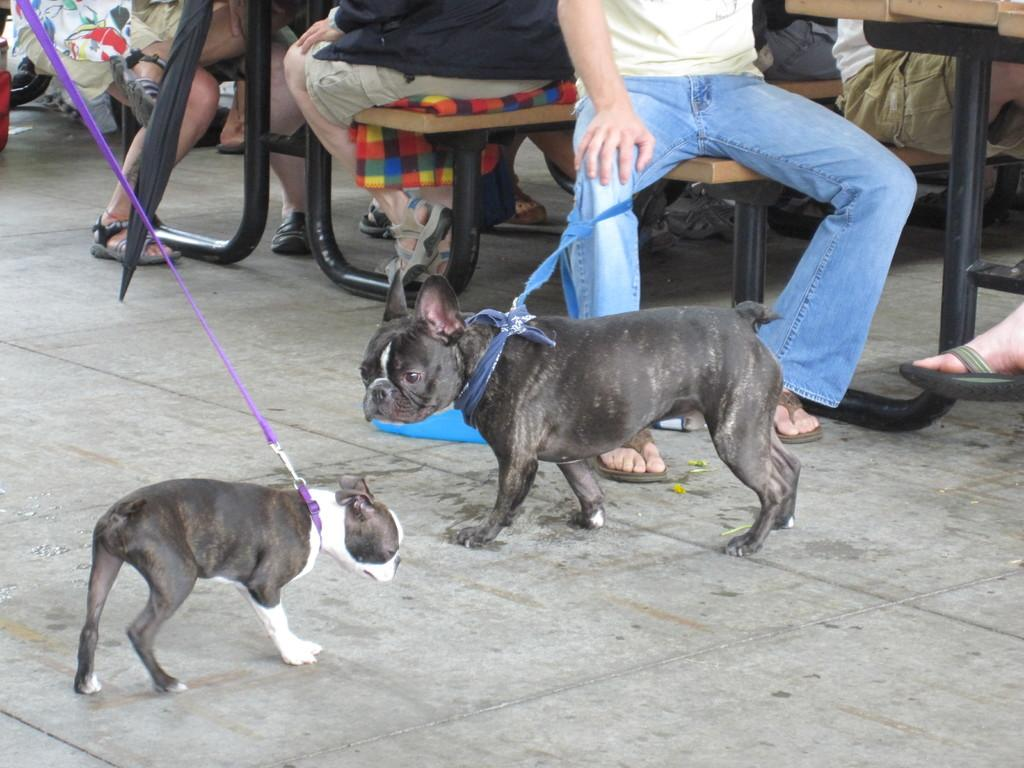How many dogs are in the image? There are two black dogs in the image. Where are the dogs positioned in the image? The dogs are standing in the front. What can be seen in the background of the image? There are people sitting on benches in the background. What object is visible in the image that might provide shade? There is an umbrella visible in the image. What is the belief of the mother of the boys in the image? There are no boys or mothers present in the image; it features two black dogs and people sitting on benches in the background. 